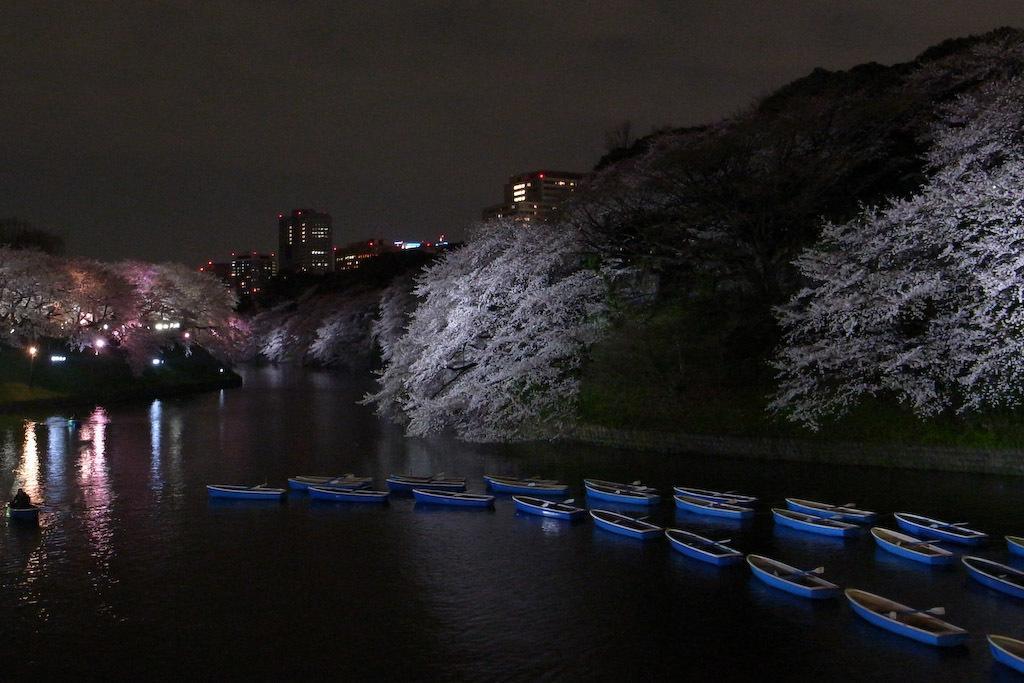Describe this image in one or two sentences. In this image we can see a few boats on the water, there are some trees, buildings and the sky. 